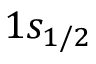Convert formula to latex. <formula><loc_0><loc_0><loc_500><loc_500>1 s _ { 1 / 2 }</formula> 